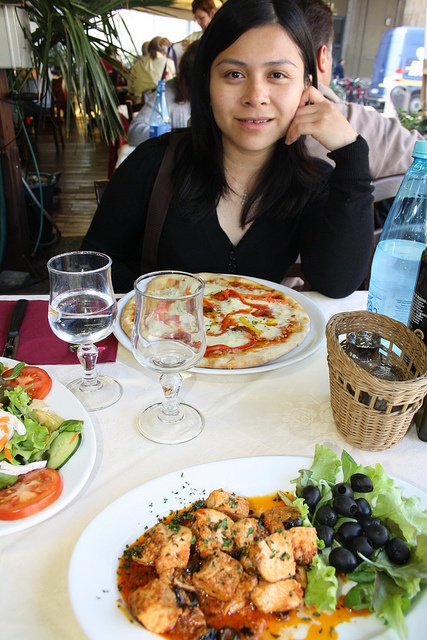Describe the objects in this image and their specific colors. I can see dining table in black, lightgray, tan, and olive tones, people in black, gray, and tan tones, potted plant in black, gray, darkgreen, and white tones, wine glass in black, lightgray, darkgray, and tan tones, and pizza in black, beige, red, and tan tones in this image. 